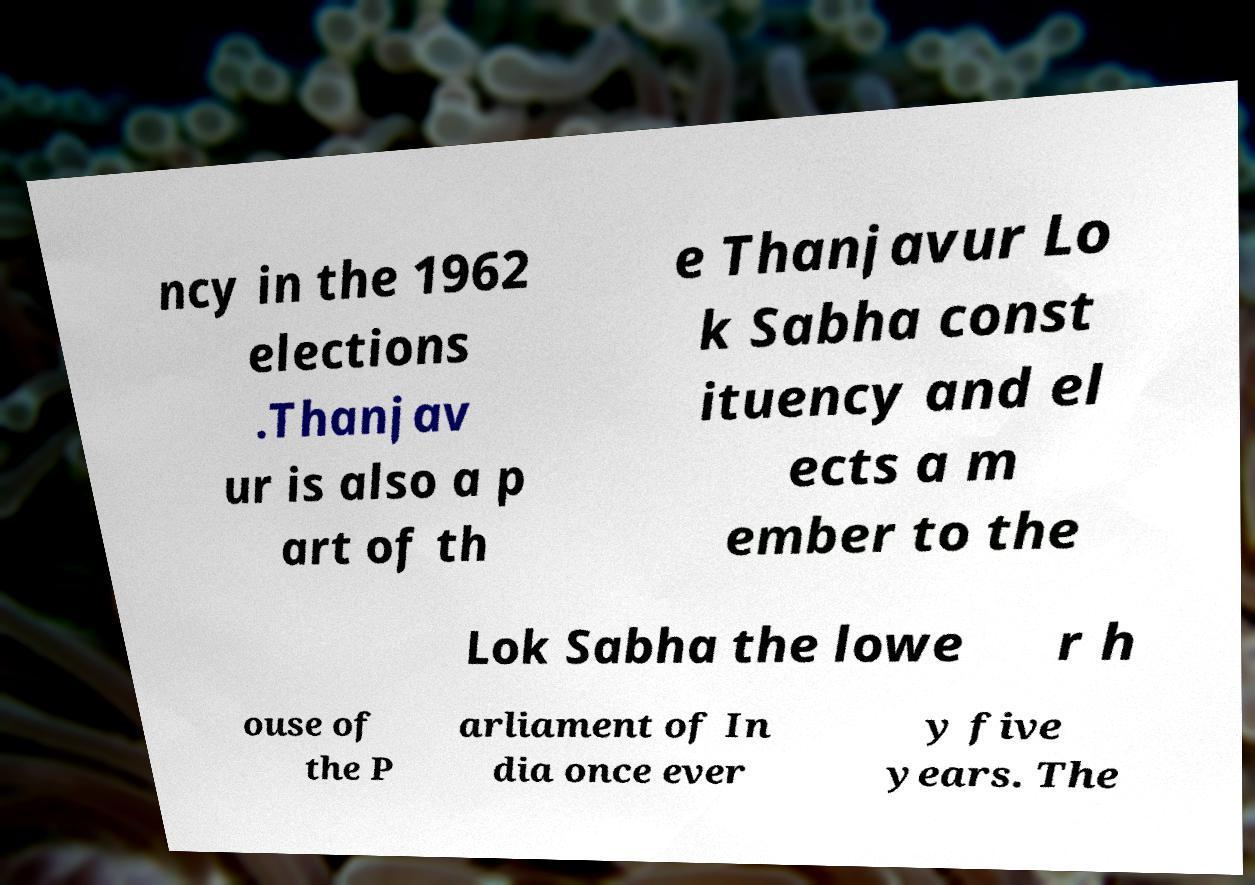Could you extract and type out the text from this image? ncy in the 1962 elections .Thanjav ur is also a p art of th e Thanjavur Lo k Sabha const ituency and el ects a m ember to the Lok Sabha the lowe r h ouse of the P arliament of In dia once ever y five years. The 